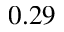Convert formula to latex. <formula><loc_0><loc_0><loc_500><loc_500>0 . 2 9</formula> 